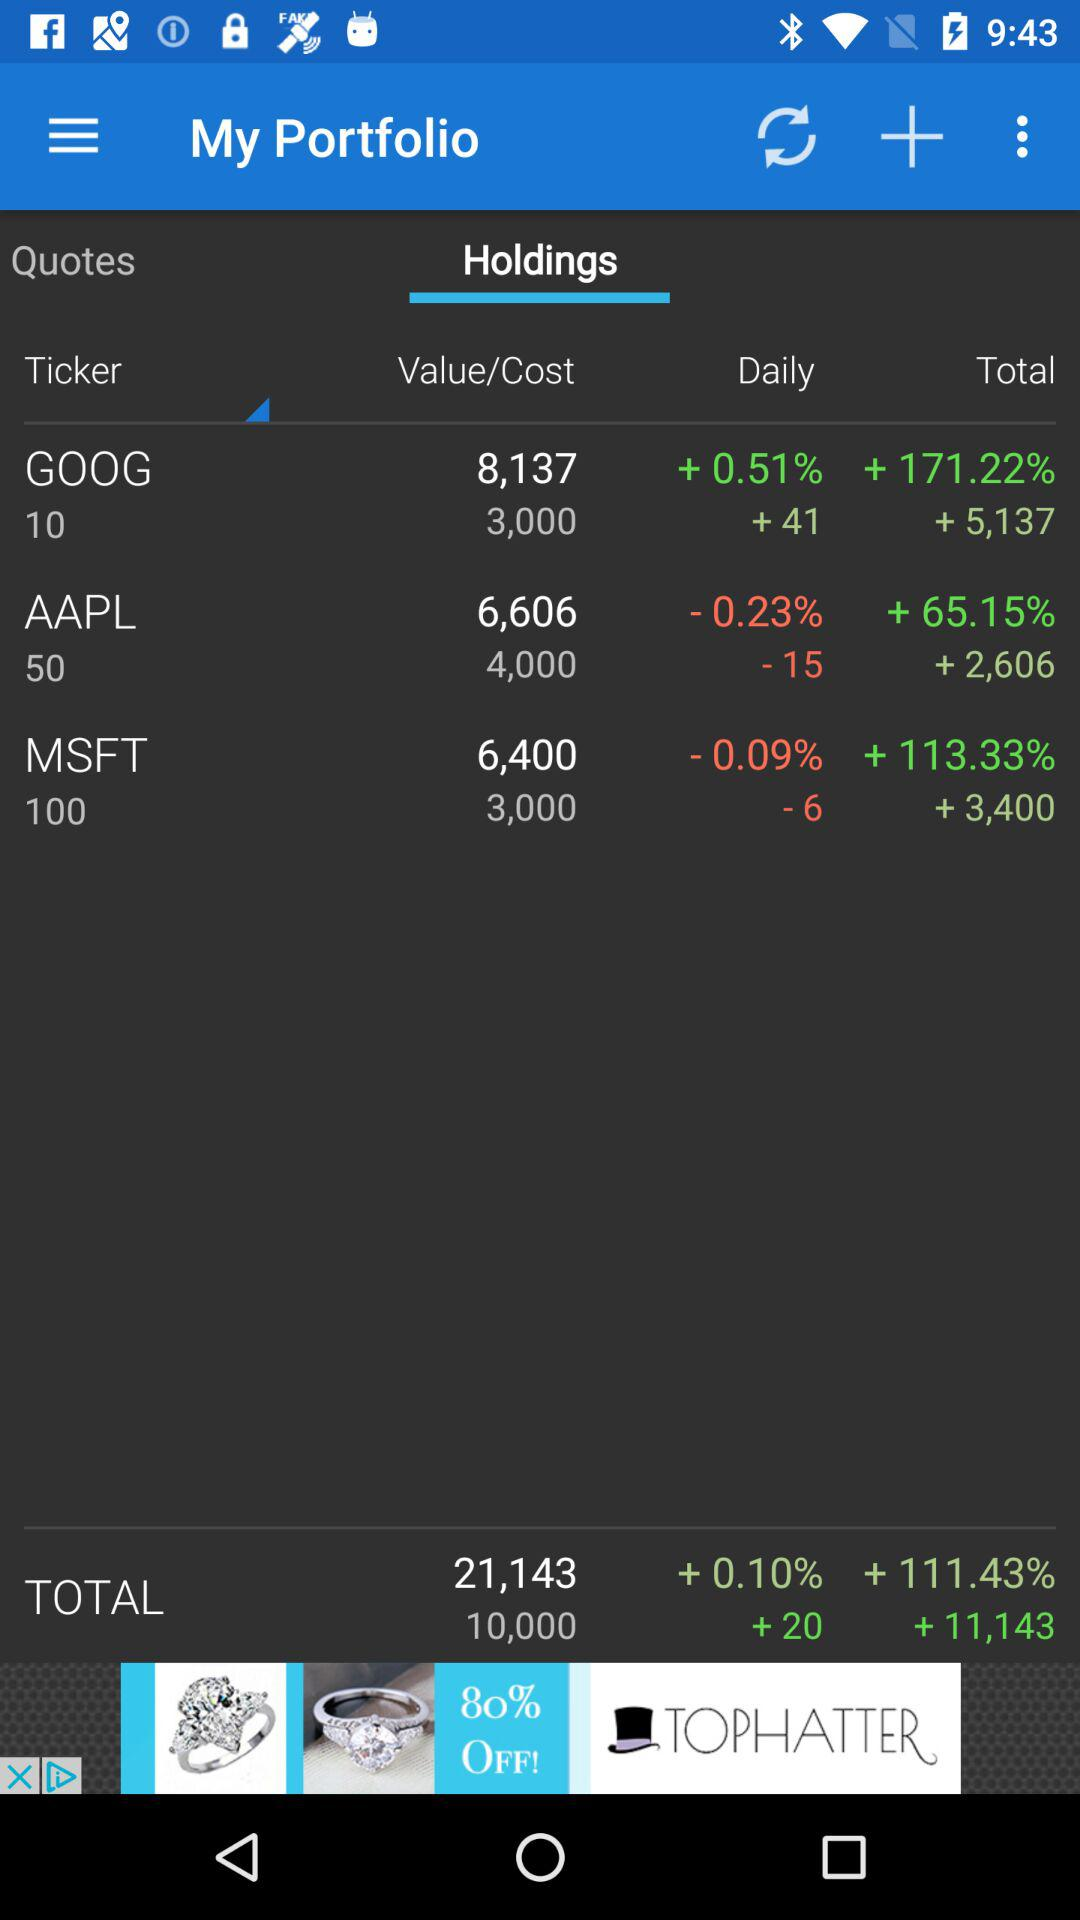What is the price of "GOOG" stock? The price of "GOOG" stock is 8,137. 